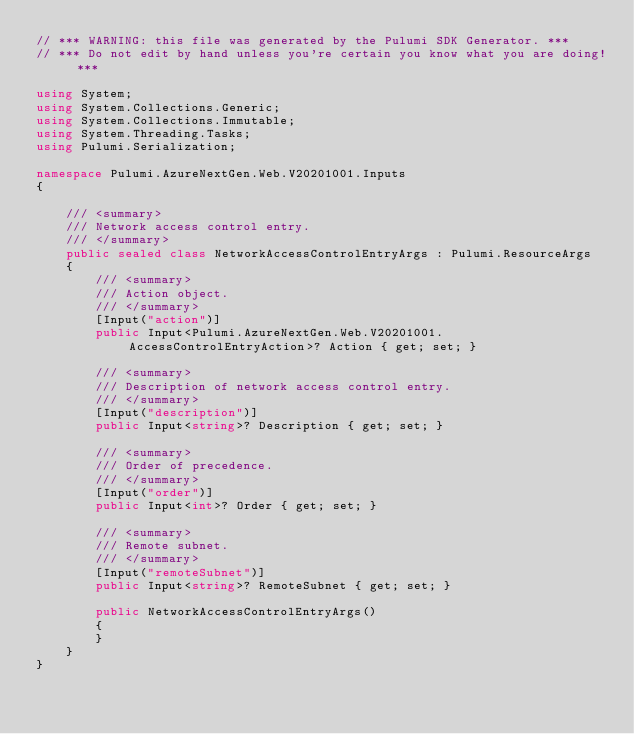Convert code to text. <code><loc_0><loc_0><loc_500><loc_500><_C#_>// *** WARNING: this file was generated by the Pulumi SDK Generator. ***
// *** Do not edit by hand unless you're certain you know what you are doing! ***

using System;
using System.Collections.Generic;
using System.Collections.Immutable;
using System.Threading.Tasks;
using Pulumi.Serialization;

namespace Pulumi.AzureNextGen.Web.V20201001.Inputs
{

    /// <summary>
    /// Network access control entry.
    /// </summary>
    public sealed class NetworkAccessControlEntryArgs : Pulumi.ResourceArgs
    {
        /// <summary>
        /// Action object.
        /// </summary>
        [Input("action")]
        public Input<Pulumi.AzureNextGen.Web.V20201001.AccessControlEntryAction>? Action { get; set; }

        /// <summary>
        /// Description of network access control entry.
        /// </summary>
        [Input("description")]
        public Input<string>? Description { get; set; }

        /// <summary>
        /// Order of precedence.
        /// </summary>
        [Input("order")]
        public Input<int>? Order { get; set; }

        /// <summary>
        /// Remote subnet.
        /// </summary>
        [Input("remoteSubnet")]
        public Input<string>? RemoteSubnet { get; set; }

        public NetworkAccessControlEntryArgs()
        {
        }
    }
}
</code> 